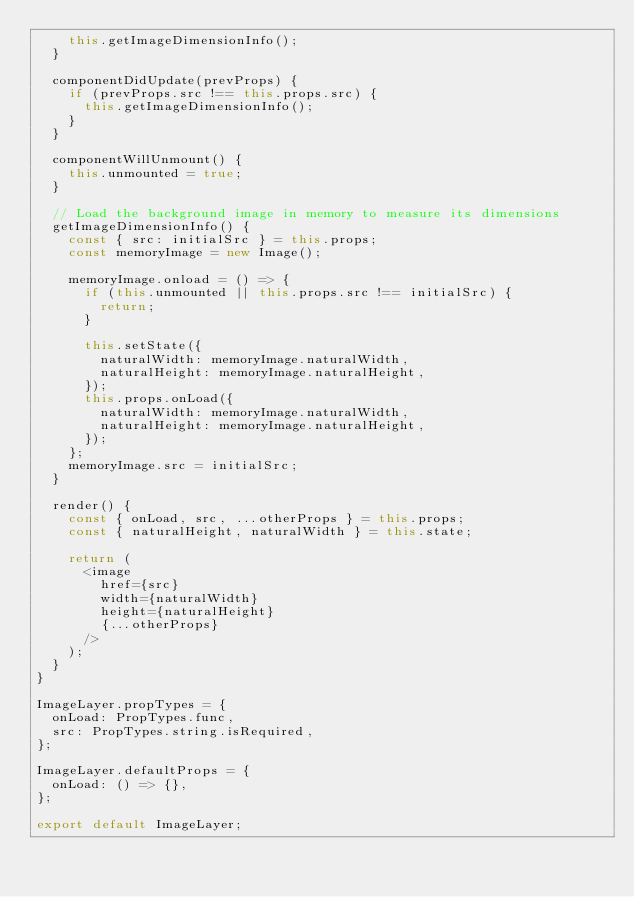<code> <loc_0><loc_0><loc_500><loc_500><_JavaScript_>    this.getImageDimensionInfo();
  }

  componentDidUpdate(prevProps) {
    if (prevProps.src !== this.props.src) {
      this.getImageDimensionInfo();
    }
  }

  componentWillUnmount() {
    this.unmounted = true;
  }

  // Load the background image in memory to measure its dimensions
  getImageDimensionInfo() {
    const { src: initialSrc } = this.props;
    const memoryImage = new Image();

    memoryImage.onload = () => {
      if (this.unmounted || this.props.src !== initialSrc) {
        return;
      }

      this.setState({
        naturalWidth: memoryImage.naturalWidth,
        naturalHeight: memoryImage.naturalHeight,
      });
      this.props.onLoad({
        naturalWidth: memoryImage.naturalWidth,
        naturalHeight: memoryImage.naturalHeight,
      });
    };
    memoryImage.src = initialSrc;
  }

  render() {
    const { onLoad, src, ...otherProps } = this.props;
    const { naturalHeight, naturalWidth } = this.state;

    return (
      <image
        href={src}
        width={naturalWidth}
        height={naturalHeight}
        {...otherProps}
      />
    );
  }
}

ImageLayer.propTypes = {
  onLoad: PropTypes.func,
  src: PropTypes.string.isRequired,
};

ImageLayer.defaultProps = {
  onLoad: () => {},
};

export default ImageLayer;
</code> 